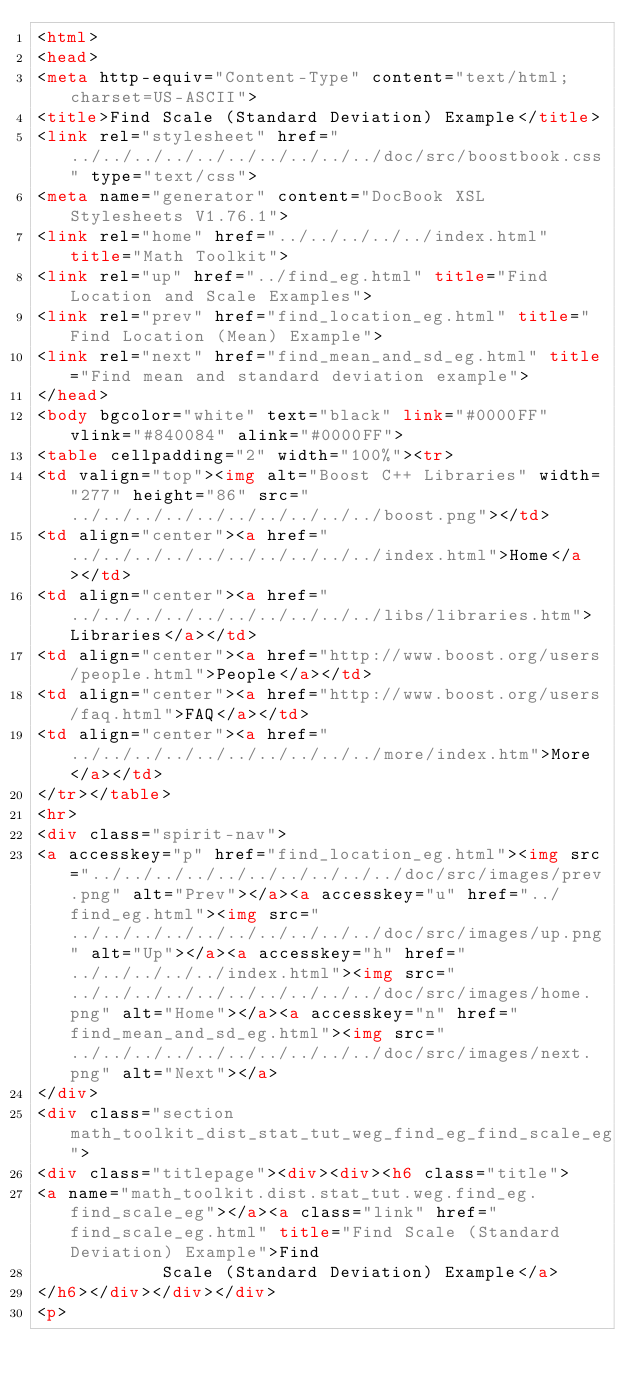Convert code to text. <code><loc_0><loc_0><loc_500><loc_500><_HTML_><html>
<head>
<meta http-equiv="Content-Type" content="text/html; charset=US-ASCII">
<title>Find Scale (Standard Deviation) Example</title>
<link rel="stylesheet" href="../../../../../../../../../../doc/src/boostbook.css" type="text/css">
<meta name="generator" content="DocBook XSL Stylesheets V1.76.1">
<link rel="home" href="../../../../../index.html" title="Math Toolkit">
<link rel="up" href="../find_eg.html" title="Find Location and Scale Examples">
<link rel="prev" href="find_location_eg.html" title="Find Location (Mean) Example">
<link rel="next" href="find_mean_and_sd_eg.html" title="Find mean and standard deviation example">
</head>
<body bgcolor="white" text="black" link="#0000FF" vlink="#840084" alink="#0000FF">
<table cellpadding="2" width="100%"><tr>
<td valign="top"><img alt="Boost C++ Libraries" width="277" height="86" src="../../../../../../../../../../boost.png"></td>
<td align="center"><a href="../../../../../../../../../../index.html">Home</a></td>
<td align="center"><a href="../../../../../../../../../../libs/libraries.htm">Libraries</a></td>
<td align="center"><a href="http://www.boost.org/users/people.html">People</a></td>
<td align="center"><a href="http://www.boost.org/users/faq.html">FAQ</a></td>
<td align="center"><a href="../../../../../../../../../../more/index.htm">More</a></td>
</tr></table>
<hr>
<div class="spirit-nav">
<a accesskey="p" href="find_location_eg.html"><img src="../../../../../../../../../../doc/src/images/prev.png" alt="Prev"></a><a accesskey="u" href="../find_eg.html"><img src="../../../../../../../../../../doc/src/images/up.png" alt="Up"></a><a accesskey="h" href="../../../../../index.html"><img src="../../../../../../../../../../doc/src/images/home.png" alt="Home"></a><a accesskey="n" href="find_mean_and_sd_eg.html"><img src="../../../../../../../../../../doc/src/images/next.png" alt="Next"></a>
</div>
<div class="section math_toolkit_dist_stat_tut_weg_find_eg_find_scale_eg">
<div class="titlepage"><div><div><h6 class="title">
<a name="math_toolkit.dist.stat_tut.weg.find_eg.find_scale_eg"></a><a class="link" href="find_scale_eg.html" title="Find Scale (Standard Deviation) Example">Find
            Scale (Standard Deviation) Example</a>
</h6></div></div></div>
<p></code> 